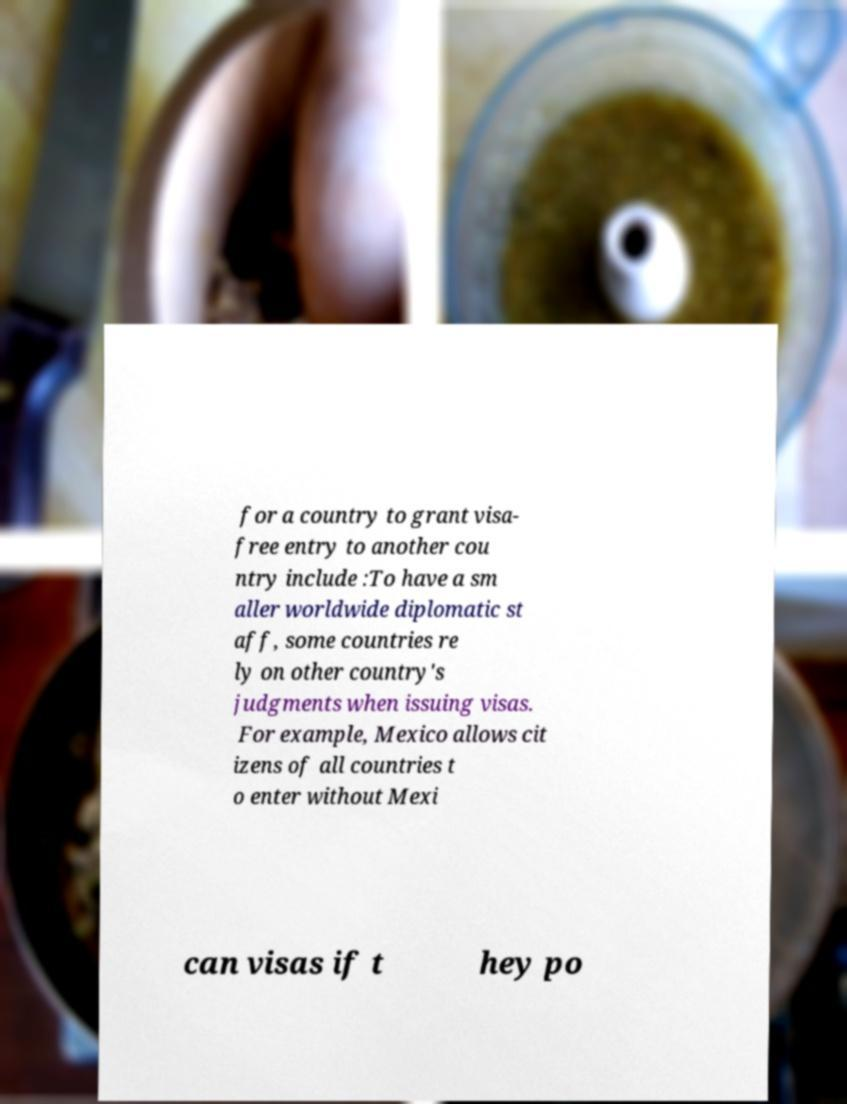I need the written content from this picture converted into text. Can you do that? for a country to grant visa- free entry to another cou ntry include :To have a sm aller worldwide diplomatic st aff, some countries re ly on other country's judgments when issuing visas. For example, Mexico allows cit izens of all countries t o enter without Mexi can visas if t hey po 